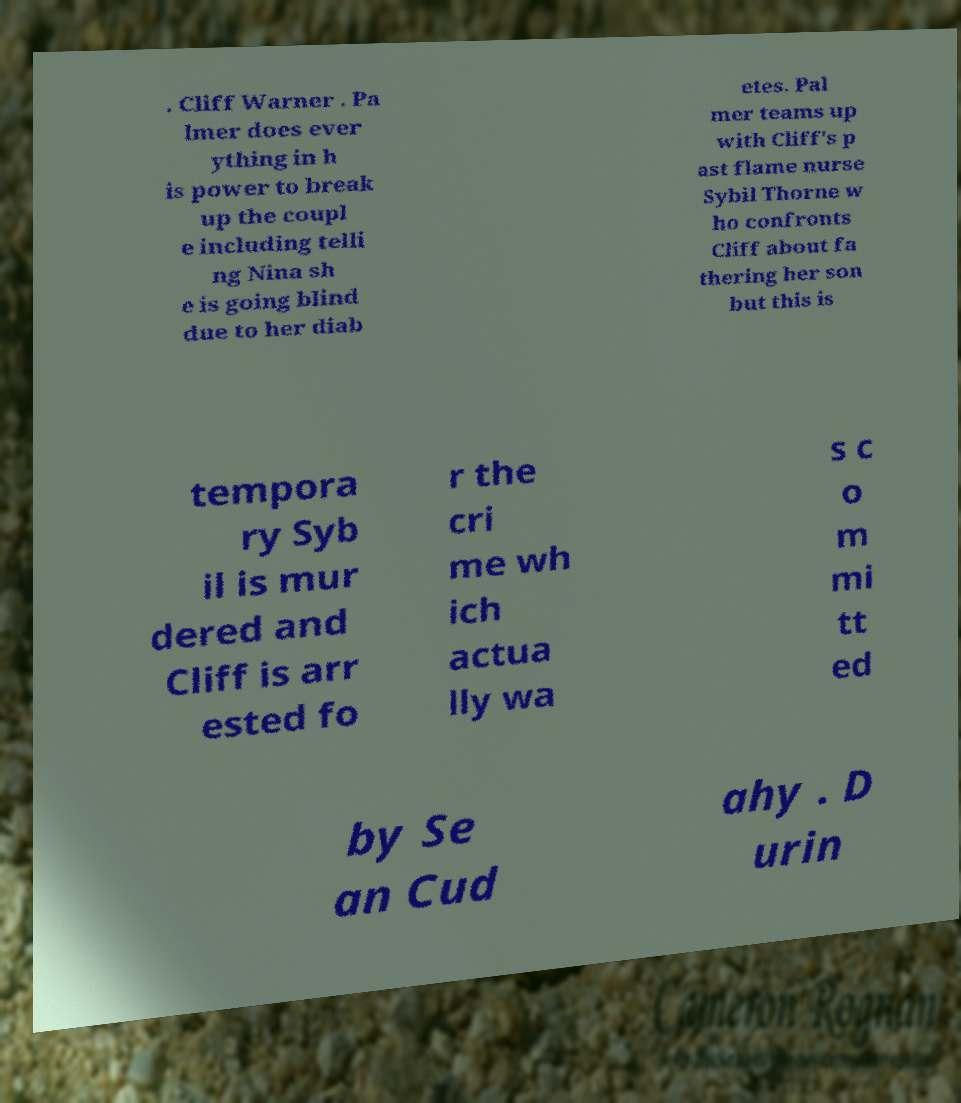I need the written content from this picture converted into text. Can you do that? . Cliff Warner . Pa lmer does ever ything in h is power to break up the coupl e including telli ng Nina sh e is going blind due to her diab etes. Pal mer teams up with Cliff's p ast flame nurse Sybil Thorne w ho confronts Cliff about fa thering her son but this is tempora ry Syb il is mur dered and Cliff is arr ested fo r the cri me wh ich actua lly wa s c o m mi tt ed by Se an Cud ahy . D urin 